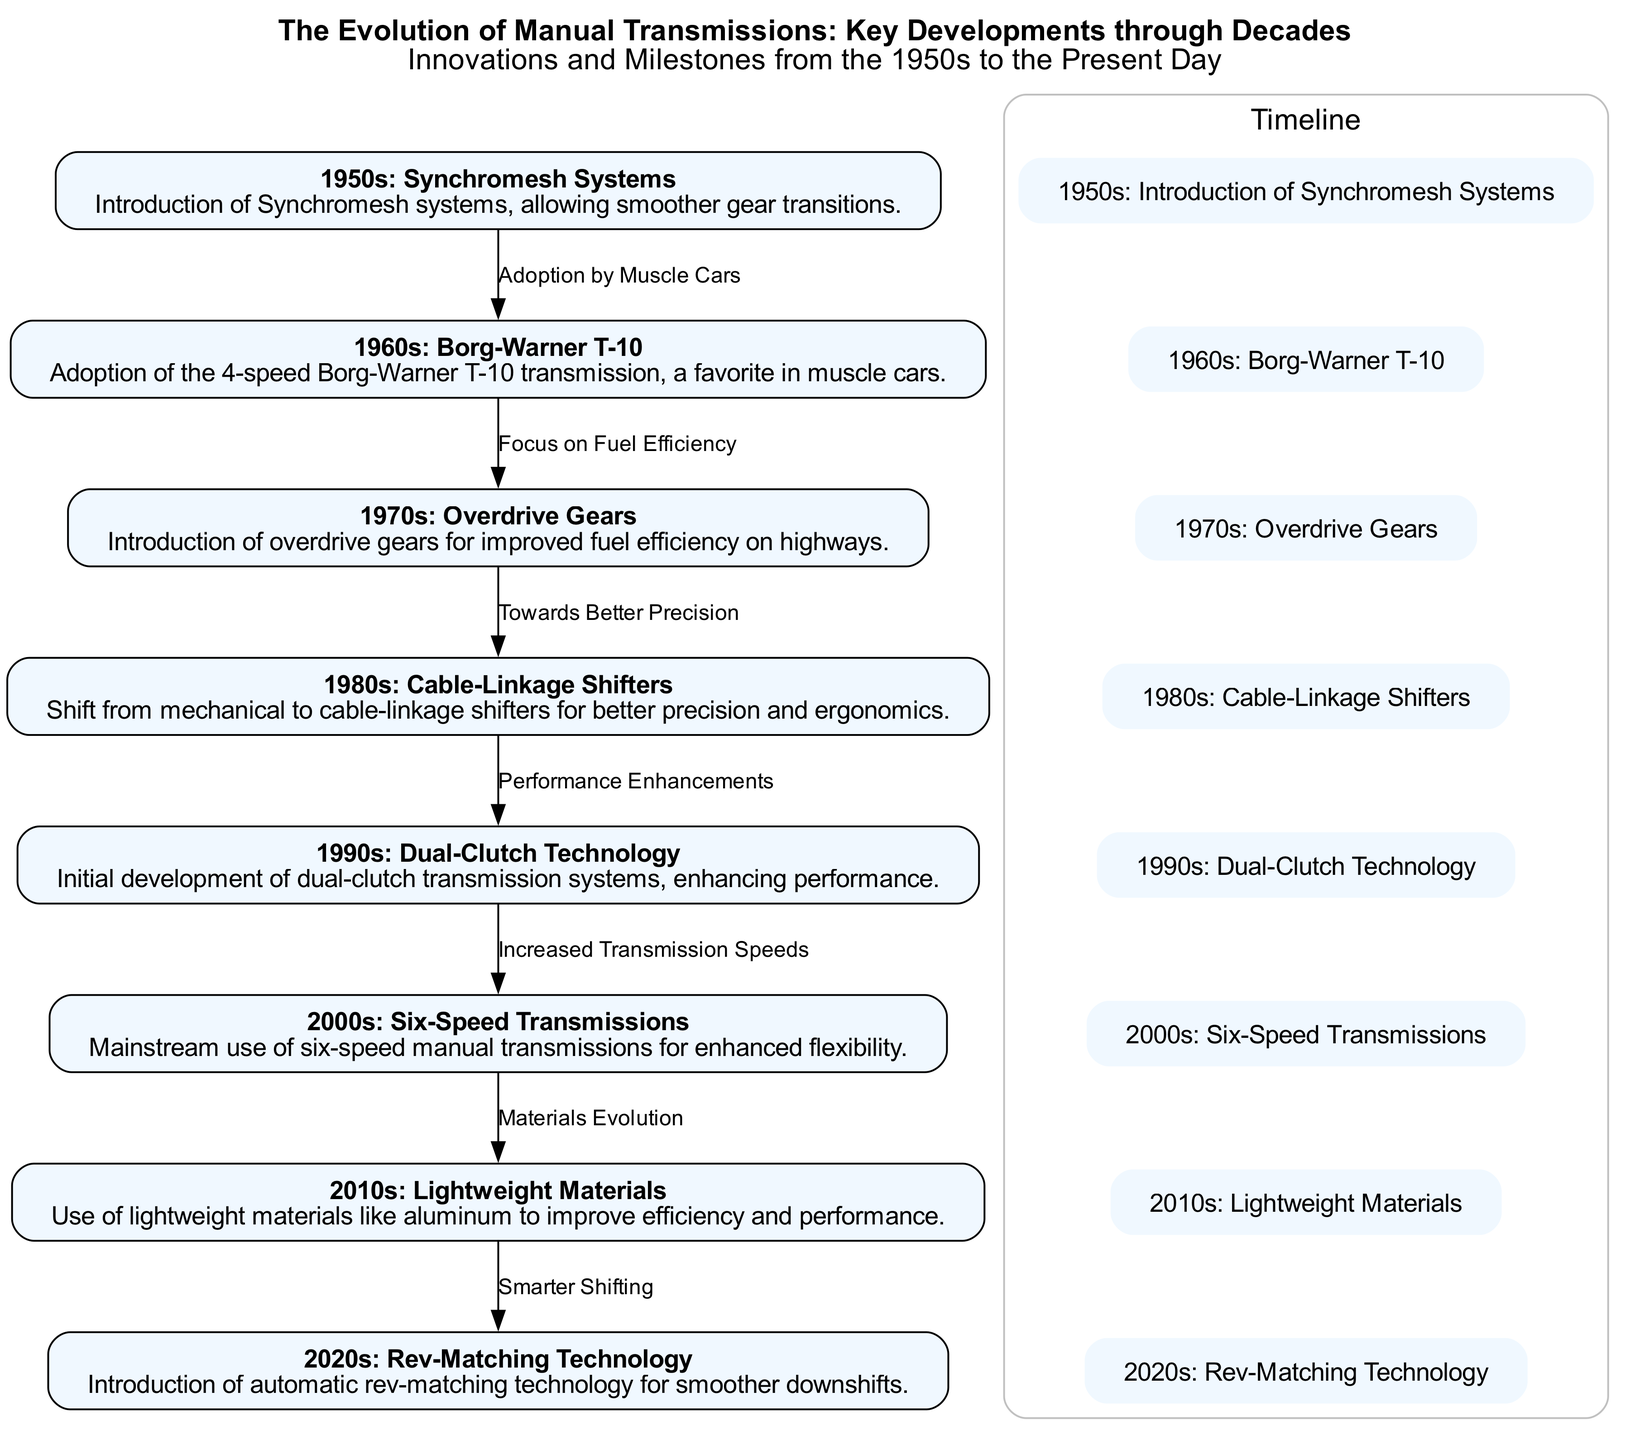What is the key innovation introduced in the 1950s? The 1950s marked the introduction of Synchromesh systems, which allowed for smoother gear transitions, a significant development in manual transmissions.
Answer: Synchromesh systems Which transmission became a favorite in muscle cars during the 1960s? The 1960s saw the adoption of the 4-speed Borg-Warner T-10 transmission, which was particularly favored in muscle cars due to its performance.
Answer: Borg-Warner T-10 How many major developments in manual transmissions are listed in the diagram? The diagram outlines eight major developments from the 1950s to 2020s, spanning different innovations in manual transmission technology.
Answer: Eight What kind of gears were introduced in the 1970s for highway driving? The 1970s introduced overdrive gears specifically aimed at enhancing fuel efficiency during highway driving, which provided better performance on long routes.
Answer: Overdrive gears What does the edge label between the 1980s and 1990s represent? The edge between the nodes for the 1980s and 1990s is labeled "Performance Enhancements," indicating a focus on improving transmission performance and efficiency during that time.
Answer: Performance Enhancements What technology was developed in the 2010s to improve transmission performance? The 2010s focused on using lightweight materials like aluminum to enhance efficiency and performance in manual transmissions, marking a shift towards material optimization.
Answer: Lightweight Materials Which technology was aimed at smoother downshifts introduced in the 2020s? The 2020s introduced rev-matching technology to allow for smoother and more efficient downshifts, enhancing the driving experience.
Answer: Rev-Matching Technology How does dual-clutch technology from the 1990s relate to earlier transmission developments? Dual-clutch technology, developed in the 1990s, follows earlier innovations and represents a performance-enhancing evolution that increased transmission speeds compared to prior systems.
Answer: Increased Transmission Speeds 